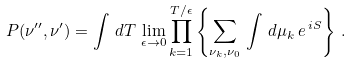<formula> <loc_0><loc_0><loc_500><loc_500>P ( \nu ^ { \prime \prime } , \nu ^ { \prime } ) = \int \, d T \, \lim _ { \epsilon \rightarrow 0 } \prod _ { k = 1 } ^ { T / \epsilon } \left \{ \sum _ { \nu _ { k } , \nu _ { 0 } } \, \int \, d \mu _ { k } \, e ^ { \, i S } \right \} \, .</formula> 